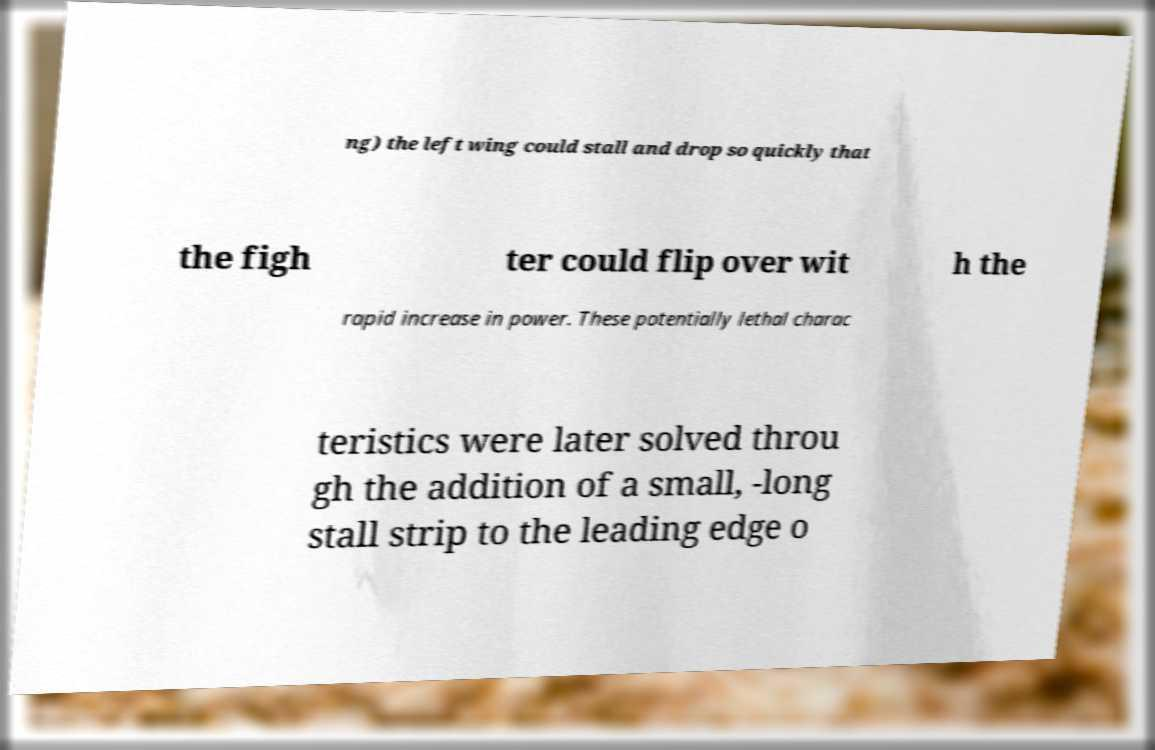Can you accurately transcribe the text from the provided image for me? ng) the left wing could stall and drop so quickly that the figh ter could flip over wit h the rapid increase in power. These potentially lethal charac teristics were later solved throu gh the addition of a small, -long stall strip to the leading edge o 